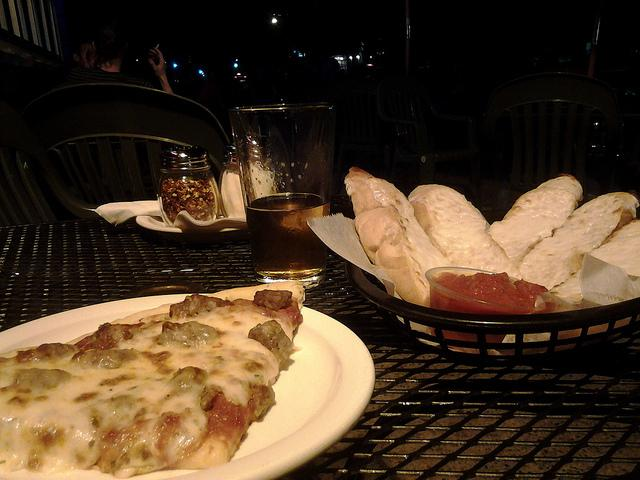What is the bread in? basket 